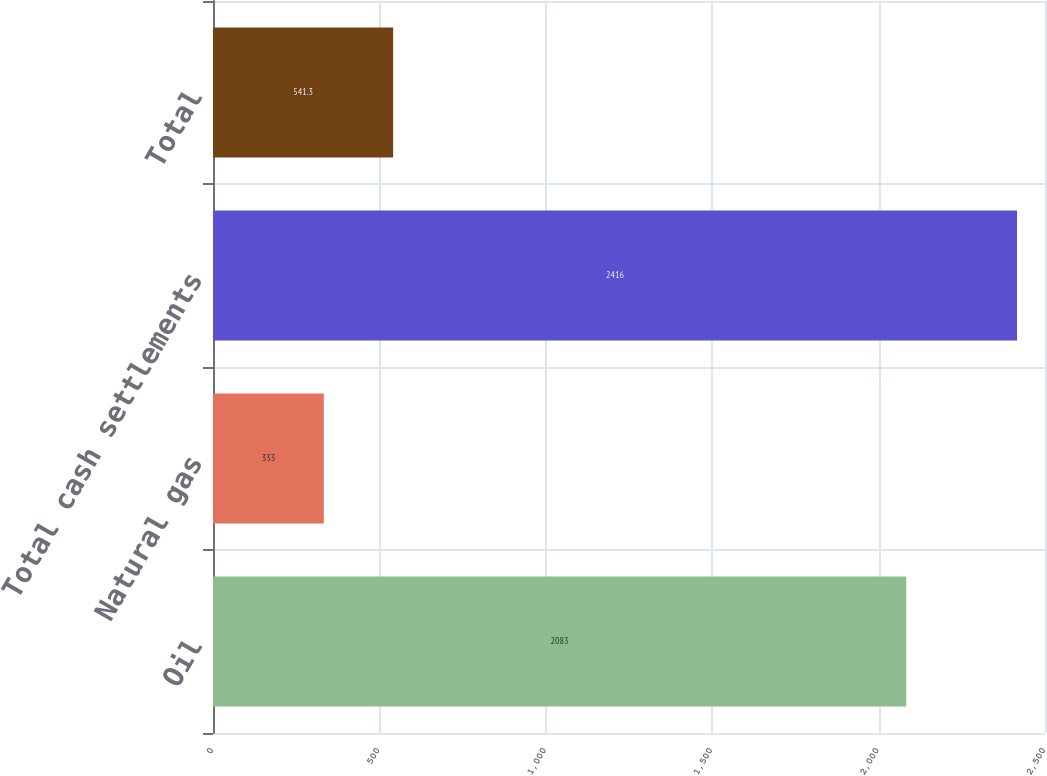<chart> <loc_0><loc_0><loc_500><loc_500><bar_chart><fcel>Oil<fcel>Natural gas<fcel>Total cash settlements<fcel>Total<nl><fcel>2083<fcel>333<fcel>2416<fcel>541.3<nl></chart> 